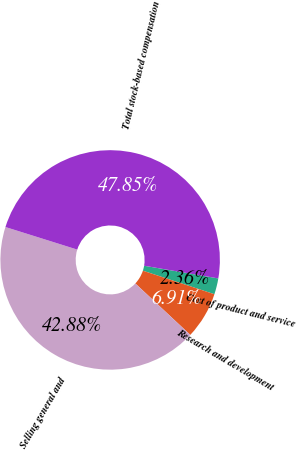Convert chart to OTSL. <chart><loc_0><loc_0><loc_500><loc_500><pie_chart><fcel>Cost of product and service<fcel>Research and development<fcel>Selling general and<fcel>Total stock-based compensation<nl><fcel>2.36%<fcel>6.91%<fcel>42.88%<fcel>47.85%<nl></chart> 